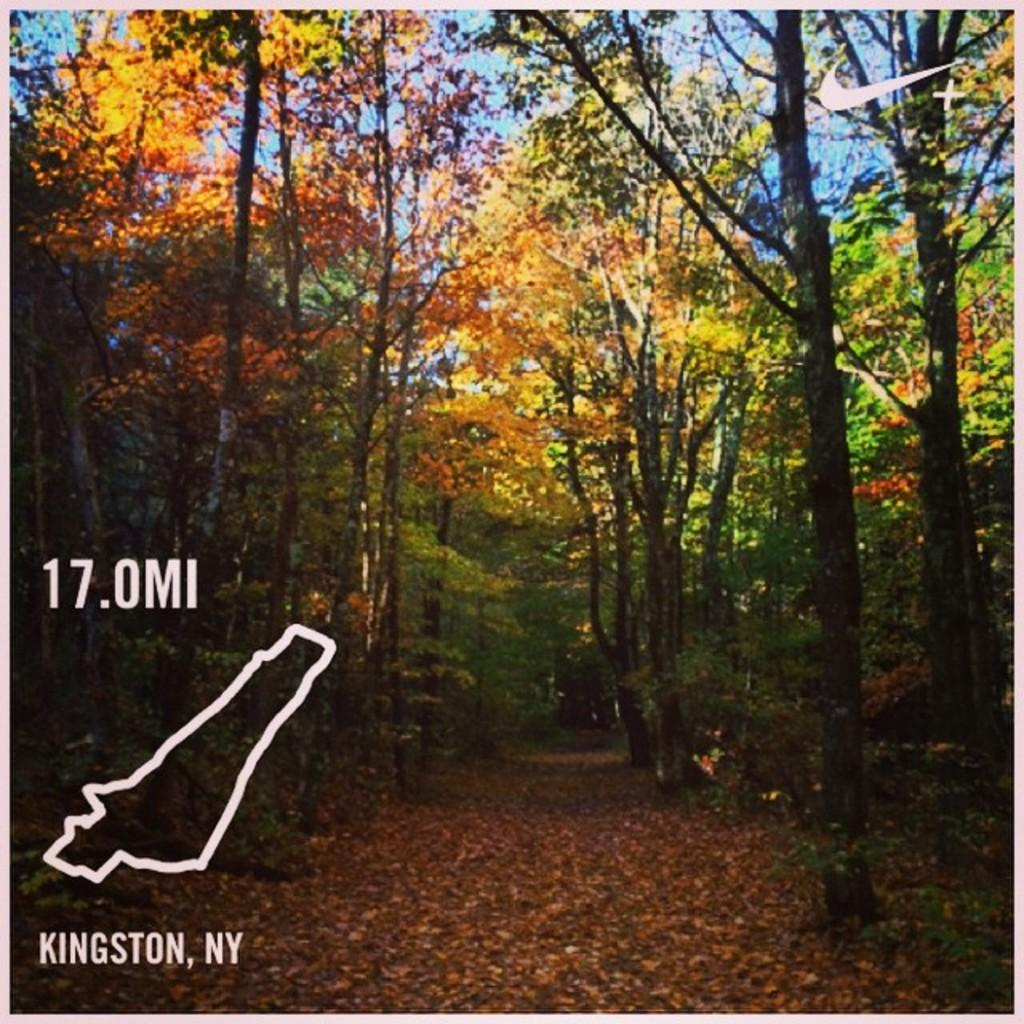What can be seen in the background of the image? The sky is visible in the background of the image. What type of environment is depicted in the image? The image appears to depict a forest area. What are the main features of the forest area? There are trees in the image, and dried leaves are present on the ground. What additional information or text is visible in the image? There is some information or text visible in the image. Are there any identifiable logos in the image? Yes, there are logos in the image. How many crates are stacked on the bridge in the image? There is no bridge or crate present in the image. What type of scale is used to weigh the animals in the forest? There is no scale or animals present in the image. 